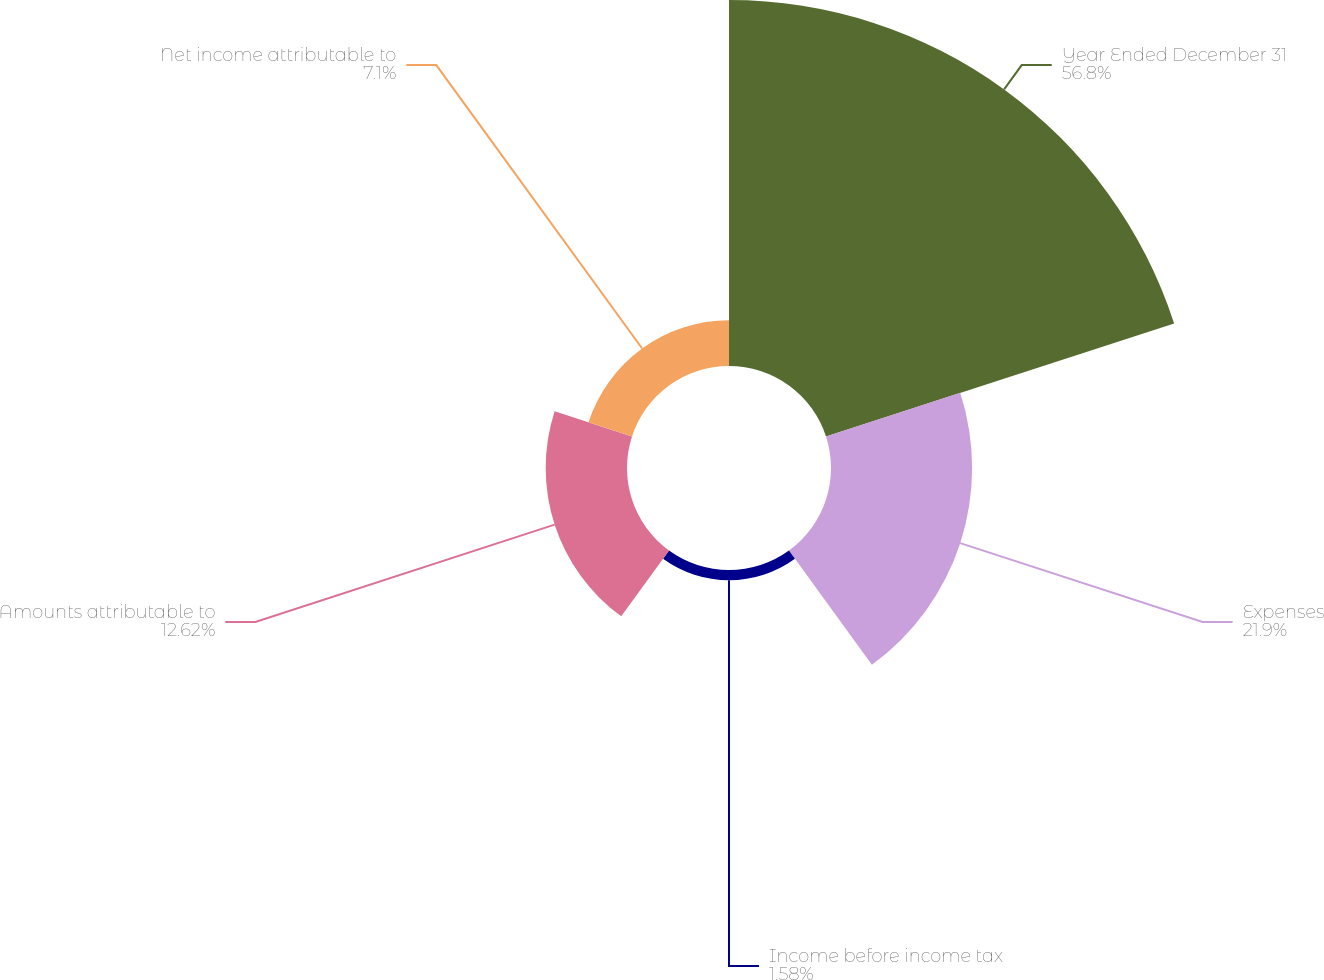Convert chart to OTSL. <chart><loc_0><loc_0><loc_500><loc_500><pie_chart><fcel>Year Ended December 31<fcel>Expenses<fcel>Income before income tax<fcel>Amounts attributable to<fcel>Net income attributable to<nl><fcel>56.8%<fcel>21.9%<fcel>1.58%<fcel>12.62%<fcel>7.1%<nl></chart> 